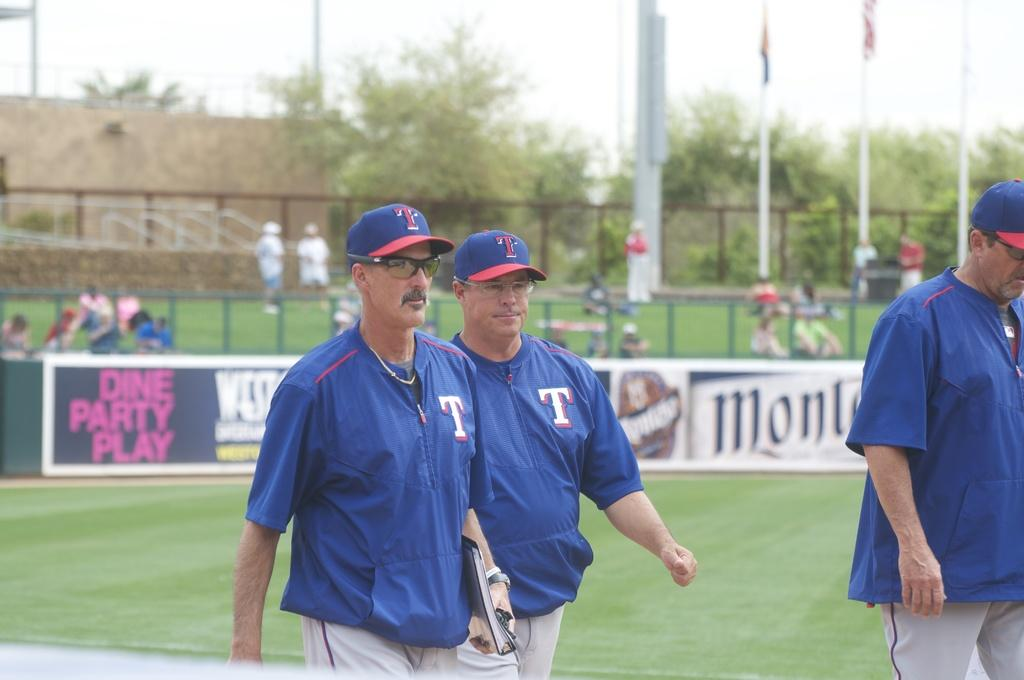<image>
Relay a brief, clear account of the picture shown. Baseball player work away from a sign that says dine party play 